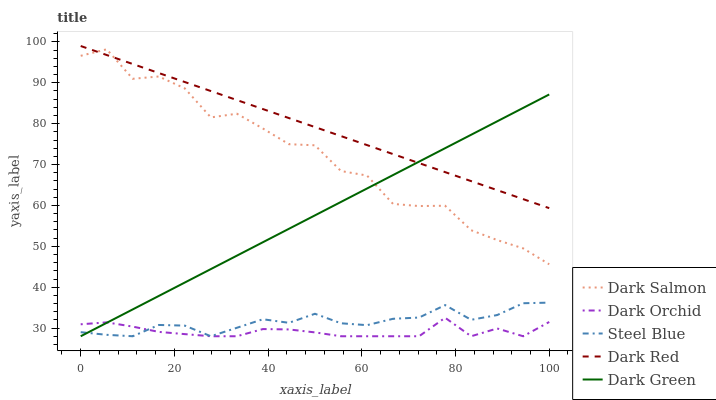Does Dark Orchid have the minimum area under the curve?
Answer yes or no. Yes. Does Dark Red have the maximum area under the curve?
Answer yes or no. Yes. Does Dark Green have the minimum area under the curve?
Answer yes or no. No. Does Dark Green have the maximum area under the curve?
Answer yes or no. No. Is Dark Red the smoothest?
Answer yes or no. Yes. Is Dark Salmon the roughest?
Answer yes or no. Yes. Is Dark Green the smoothest?
Answer yes or no. No. Is Dark Green the roughest?
Answer yes or no. No. Does Dark Green have the lowest value?
Answer yes or no. Yes. Does Dark Salmon have the lowest value?
Answer yes or no. No. Does Dark Red have the highest value?
Answer yes or no. Yes. Does Dark Green have the highest value?
Answer yes or no. No. Is Dark Orchid less than Dark Red?
Answer yes or no. Yes. Is Dark Red greater than Dark Orchid?
Answer yes or no. Yes. Does Dark Red intersect Dark Green?
Answer yes or no. Yes. Is Dark Red less than Dark Green?
Answer yes or no. No. Is Dark Red greater than Dark Green?
Answer yes or no. No. Does Dark Orchid intersect Dark Red?
Answer yes or no. No. 